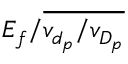Convert formula to latex. <formula><loc_0><loc_0><loc_500><loc_500>E _ { f } / \overline { { v _ { d _ { p } } / v _ { D _ { p } } } }</formula> 